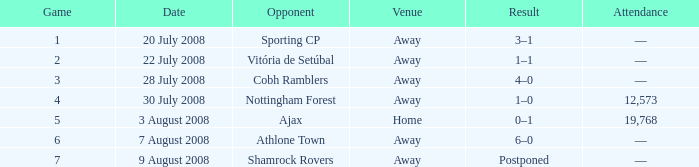What is the effect of the contest with a game number over 6 and an external site? Postponed. 